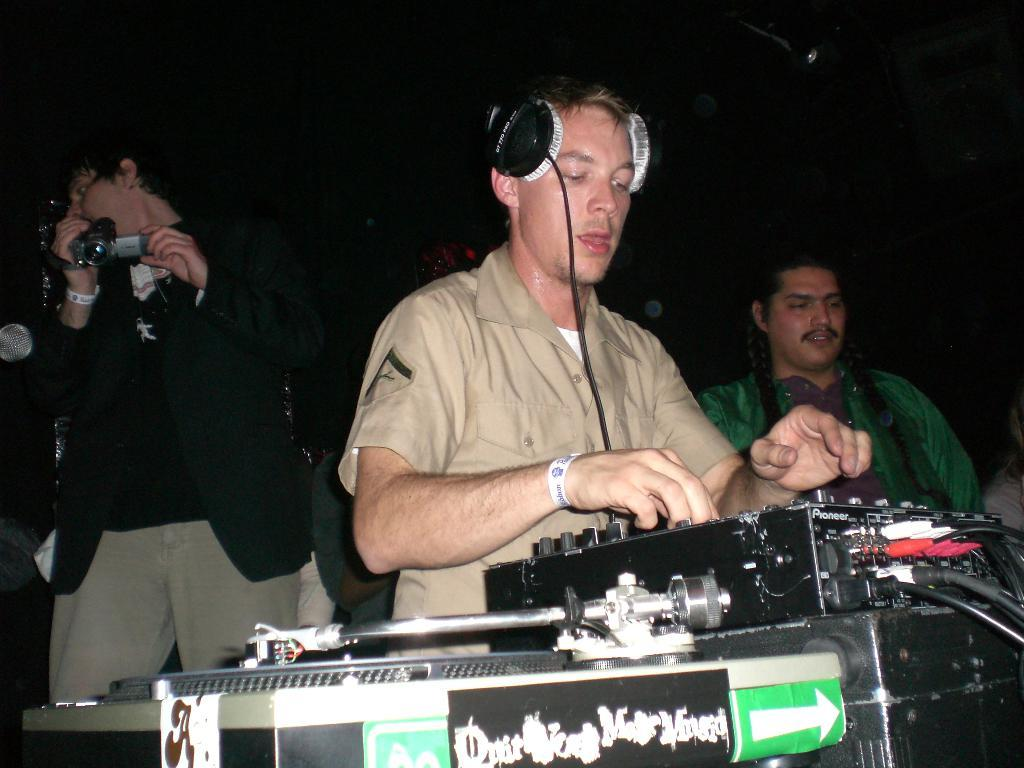How many people are in the image? There are three persons in the image. What object related to music can be seen in the image? There is a music controller in the image. What device is used for listening to audio in the image? Headphones are visible in the image. What is the man on the left side holding? The man on the left side is holding a camera. What type of electrical components are present in the image? There are wires in the image. What type of nest can be seen in the image? There is no nest present in the image. What disease is being treated by the persons in the image? There is no indication of any disease or medical treatment in the image. 